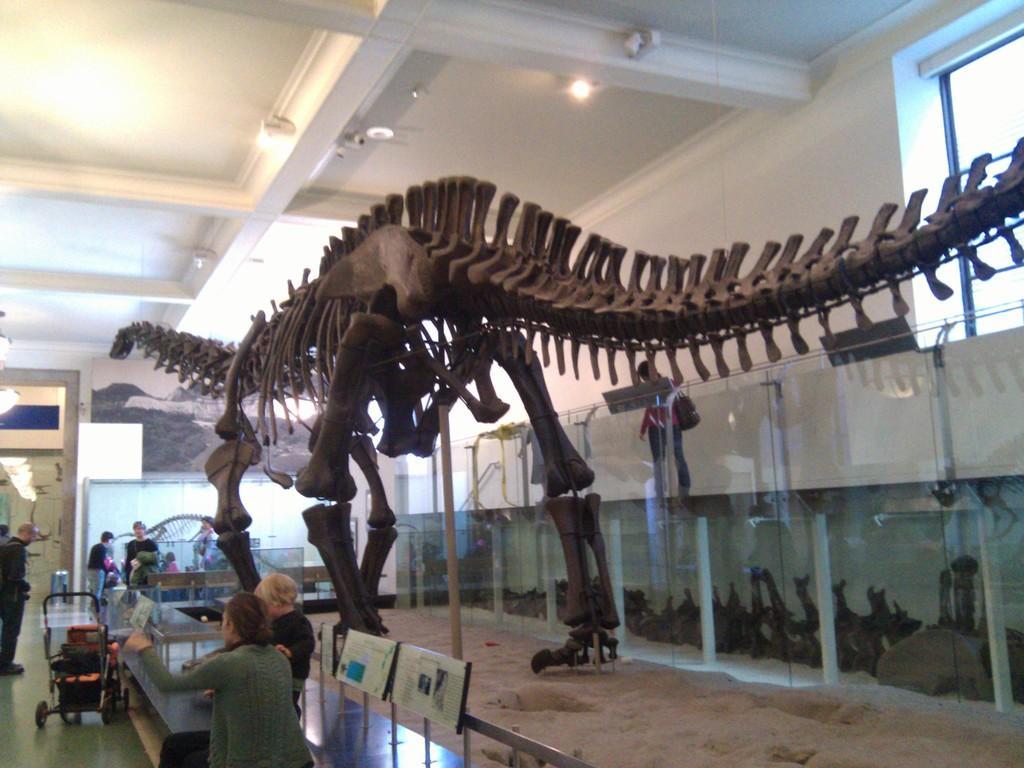Can you describe this image briefly? In this image I can see the skeleton of the animal. I can see few people, boards, glass walls, windows, wall, lights and the trolley. 